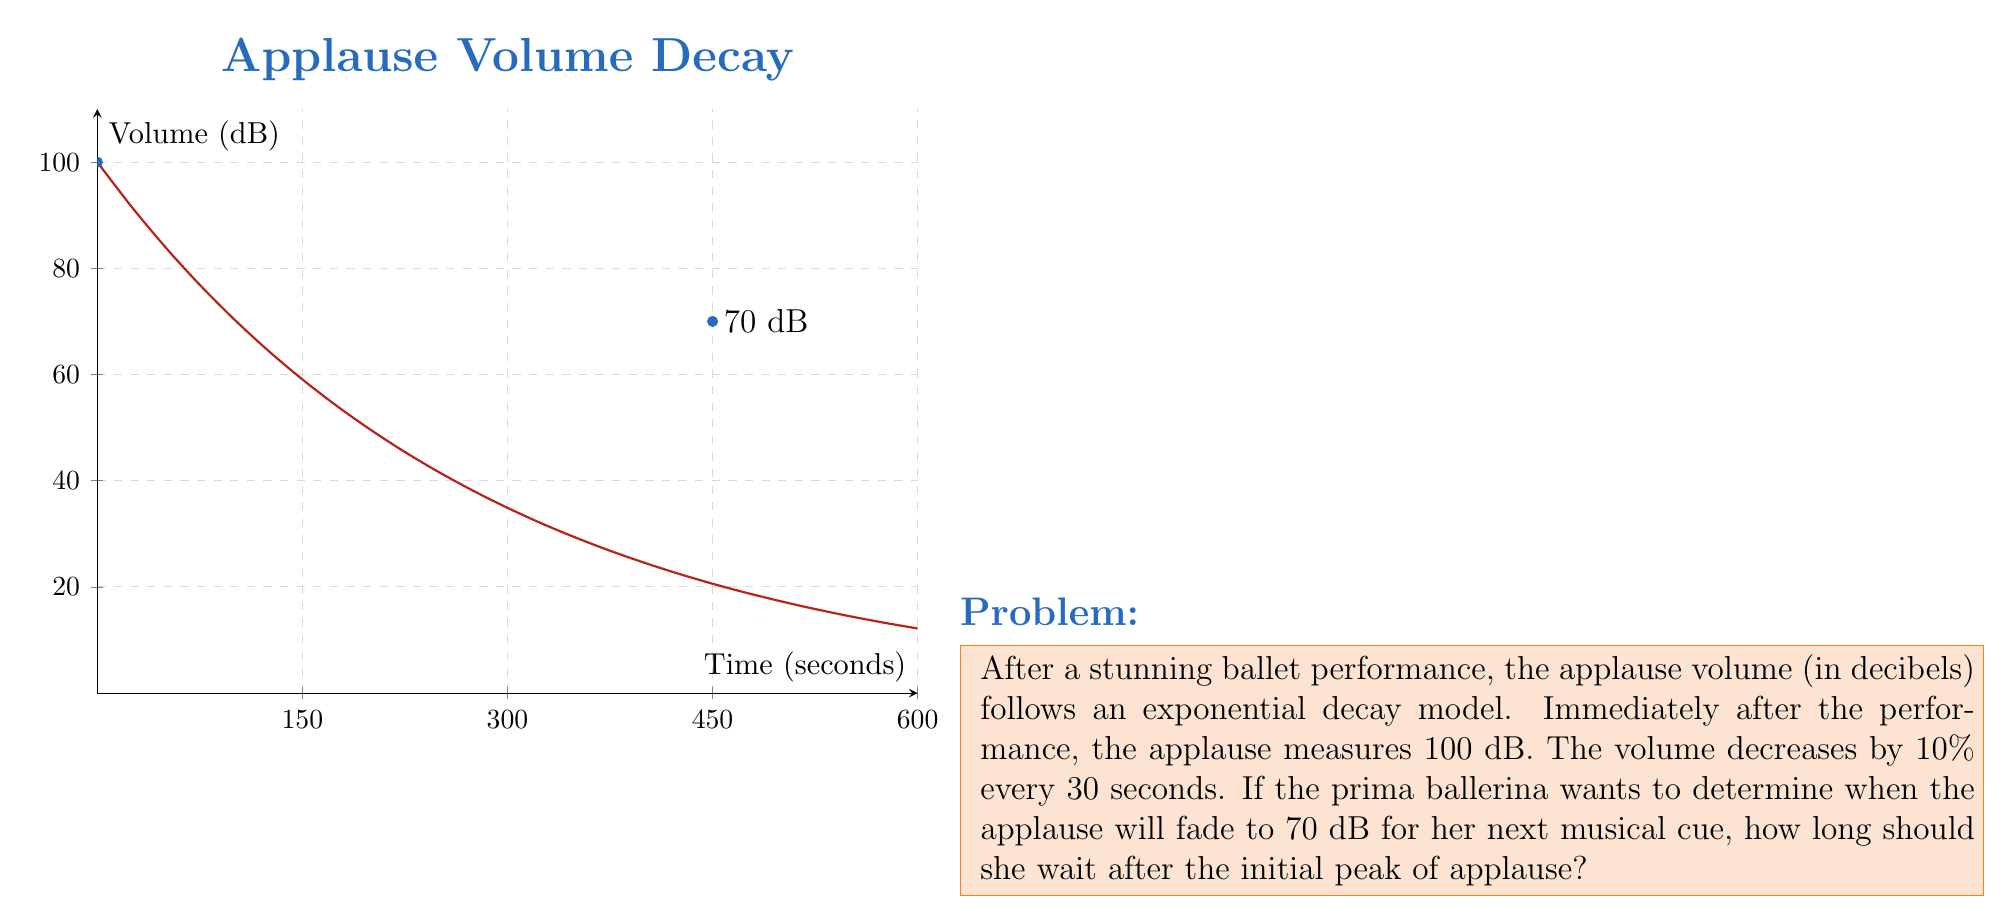Could you help me with this problem? Let's approach this step-by-step:

1) The exponential decay model is given by the equation:
   $$V(t) = V_0 e^{-kt}$$
   where $V(t)$ is the volume at time $t$, $V_0$ is the initial volume, and $k$ is the decay constant.

2) We're given that $V_0 = 100$ dB.

3) To find $k$, we use the information that the volume decreases by 10% every 30 seconds:
   $$90 = 100 e^{-k(30)}$$
   $$0.9 = e^{-30k}$$
   $$\ln(0.9) = -30k$$
   $$k = -\frac{\ln(0.9)}{30} \approx 0.00351$$

4) Now our model is:
   $$V(t) = 100 e^{-0.00351t}$$

5) We want to find $t$ when $V(t) = 70$:
   $$70 = 100 e^{-0.00351t}$$
   $$0.7 = e^{-0.00351t}$$
   $$\ln(0.7) = -0.00351t$$
   $$t = -\frac{\ln(0.7)}{0.00351} \approx 101.3 \text{ seconds}$$

6) Converting to minutes and seconds:
   101.3 seconds = 1 minute and 41.3 seconds ≈ 1 minute and 41 seconds
Answer: 1 minute and 41 seconds 